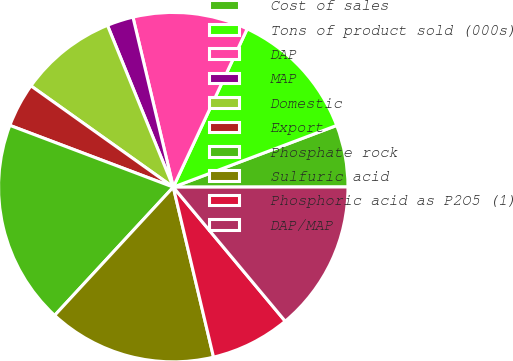Convert chart. <chart><loc_0><loc_0><loc_500><loc_500><pie_chart><fcel>Cost of sales<fcel>Tons of product sold (000s)<fcel>DAP<fcel>MAP<fcel>Domestic<fcel>Export<fcel>Phosphate rock<fcel>Sulfuric acid<fcel>Phosphoric acid as P2O5 (1)<fcel>DAP/MAP<nl><fcel>5.73%<fcel>12.3%<fcel>10.66%<fcel>2.44%<fcel>9.01%<fcel>4.09%<fcel>18.87%<fcel>15.58%<fcel>7.37%<fcel>13.94%<nl></chart> 